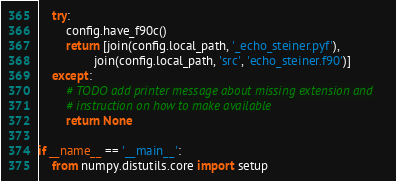Convert code to text. <code><loc_0><loc_0><loc_500><loc_500><_Python_>    try:
        config.have_f90c()
        return [join(config.local_path, '_echo_steiner.pyf'),
                join(config.local_path, 'src', 'echo_steiner.f90')]
    except:
        # TODO add printer message about missing extension and
        # instruction on how to make available
        return None

if __name__ == '__main__':
    from numpy.distutils.core import setup</code> 